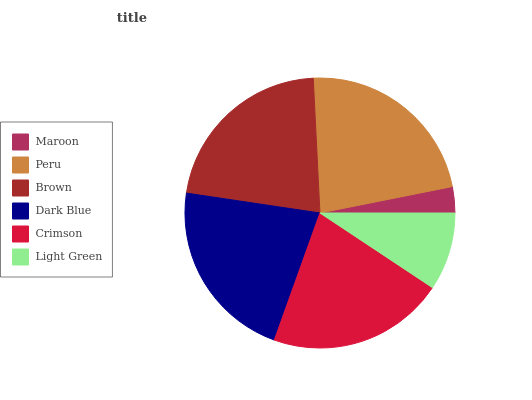Is Maroon the minimum?
Answer yes or no. Yes. Is Peru the maximum?
Answer yes or no. Yes. Is Brown the minimum?
Answer yes or no. No. Is Brown the maximum?
Answer yes or no. No. Is Peru greater than Brown?
Answer yes or no. Yes. Is Brown less than Peru?
Answer yes or no. Yes. Is Brown greater than Peru?
Answer yes or no. No. Is Peru less than Brown?
Answer yes or no. No. Is Brown the high median?
Answer yes or no. Yes. Is Crimson the low median?
Answer yes or no. Yes. Is Dark Blue the high median?
Answer yes or no. No. Is Brown the low median?
Answer yes or no. No. 